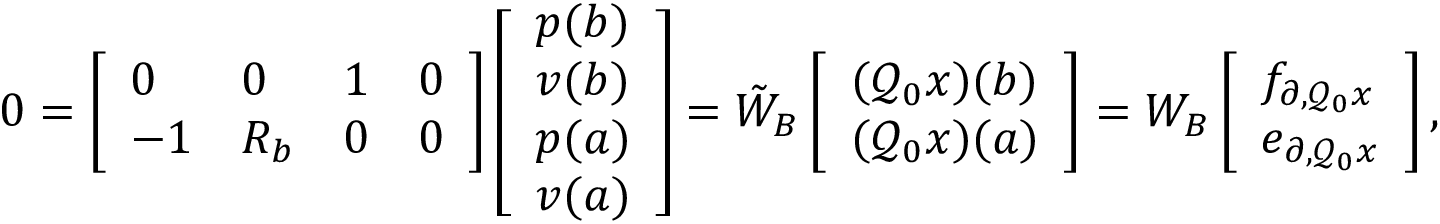Convert formula to latex. <formula><loc_0><loc_0><loc_500><loc_500>0 = \left [ \begin{array} { l l l l } { 0 } & { 0 } & { 1 } & { 0 } \\ { - 1 } & { R _ { b } } & { 0 } & { 0 } \end{array} \right ] \left [ \begin{array} { l } { p ( b ) } \\ { v ( b ) } \\ { p ( a ) } \\ { v ( a ) } \end{array} \right ] = \tilde { W } _ { B } \left [ \begin{array} { l } { ( \mathcal { Q } _ { 0 } x ) ( b ) } \\ { ( \mathcal { Q } _ { 0 } x ) ( a ) } \end{array} \right ] = W _ { B } \left [ \begin{array} { l } { f _ { \partial , \mathcal { Q } _ { 0 } x } } \\ { e _ { \partial , \mathcal { Q } _ { 0 } x } } \end{array} \right ] ,</formula> 